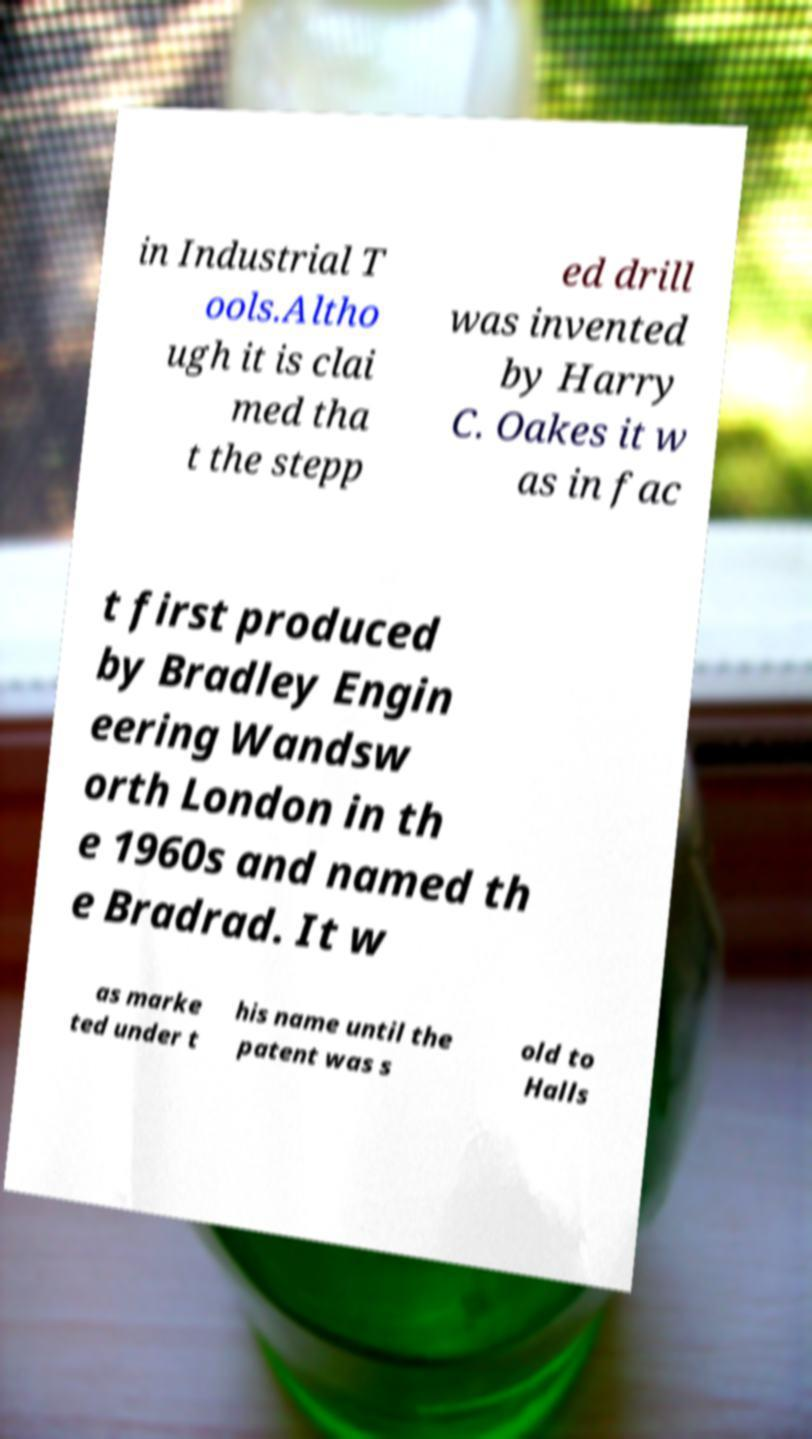I need the written content from this picture converted into text. Can you do that? in Industrial T ools.Altho ugh it is clai med tha t the stepp ed drill was invented by Harry C. Oakes it w as in fac t first produced by Bradley Engin eering Wandsw orth London in th e 1960s and named th e Bradrad. It w as marke ted under t his name until the patent was s old to Halls 